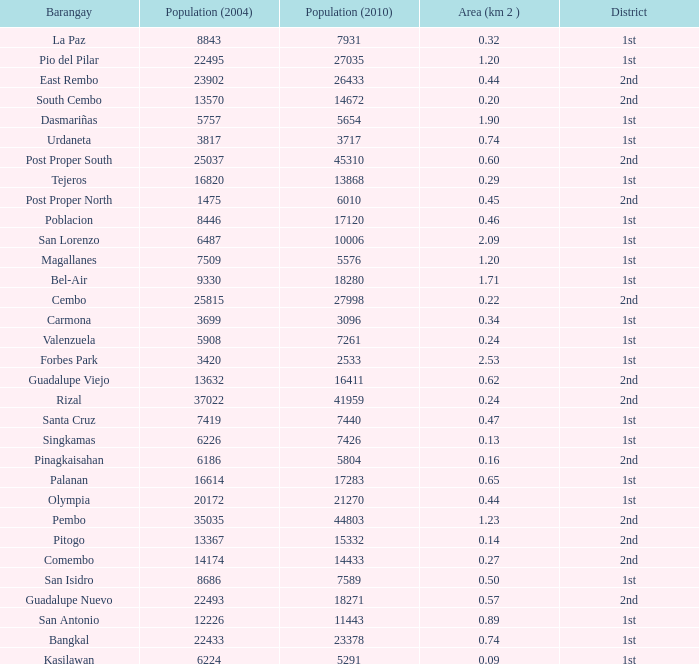What is the area where barangay is guadalupe viejo? 0.62. 